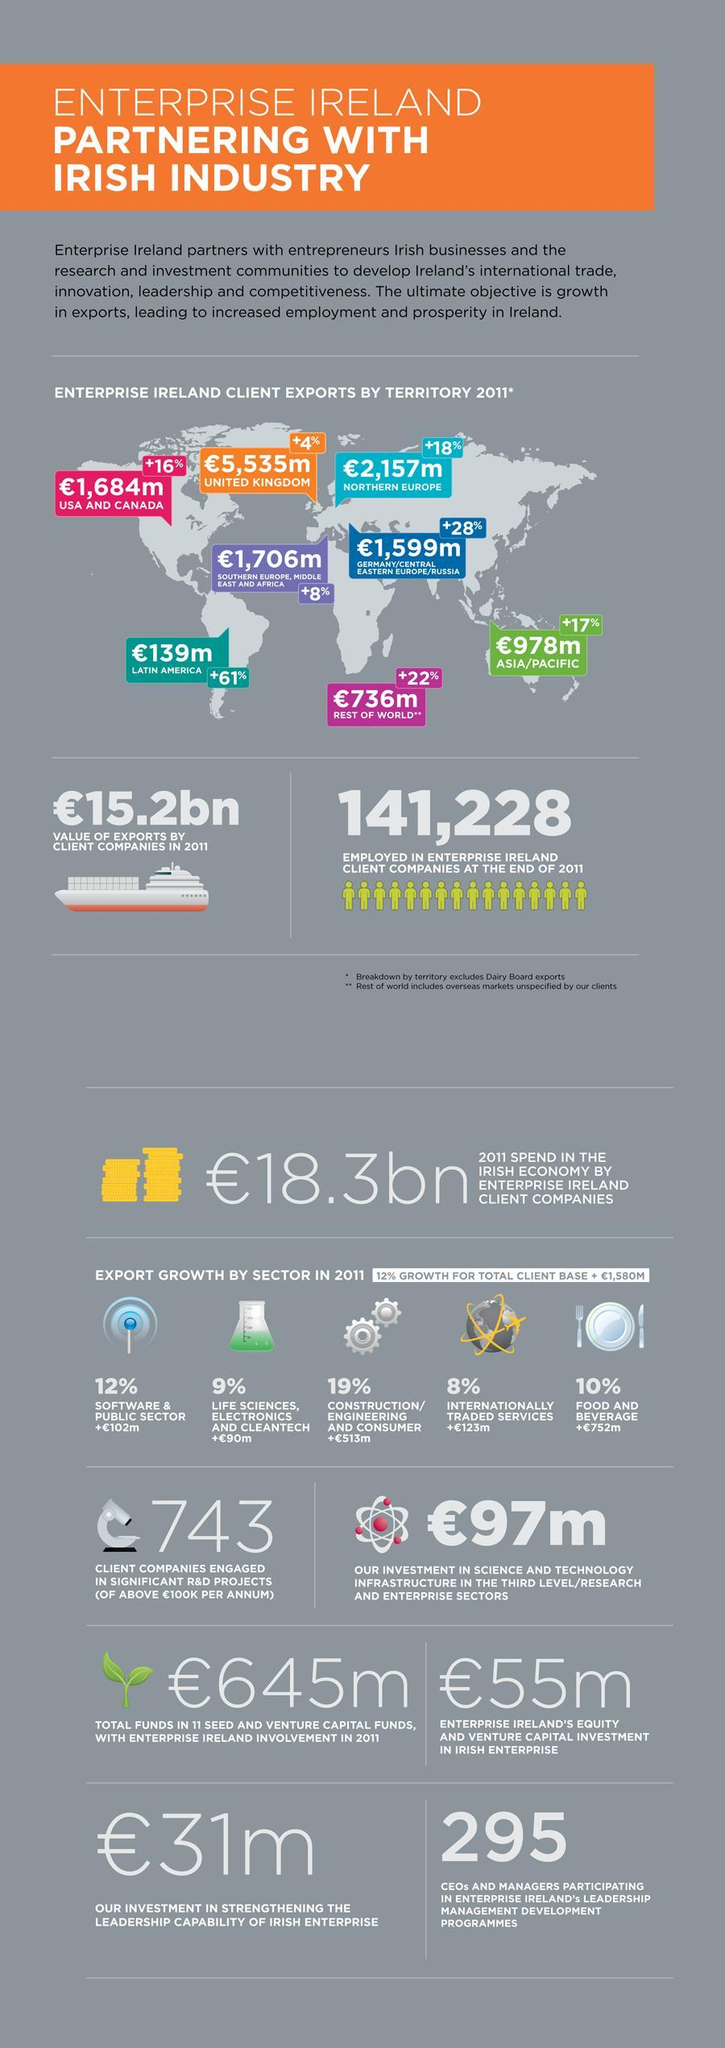Which sector had the highest export growth in 2011?
Answer the question with a short phrase. CONSTRUCTION/ENGINEERING AND CONSUMER To which country is the export highest as of 2011? UNITED KINGDOM To which country was there maximum percentage increase in export ? LATIN AMERICA 